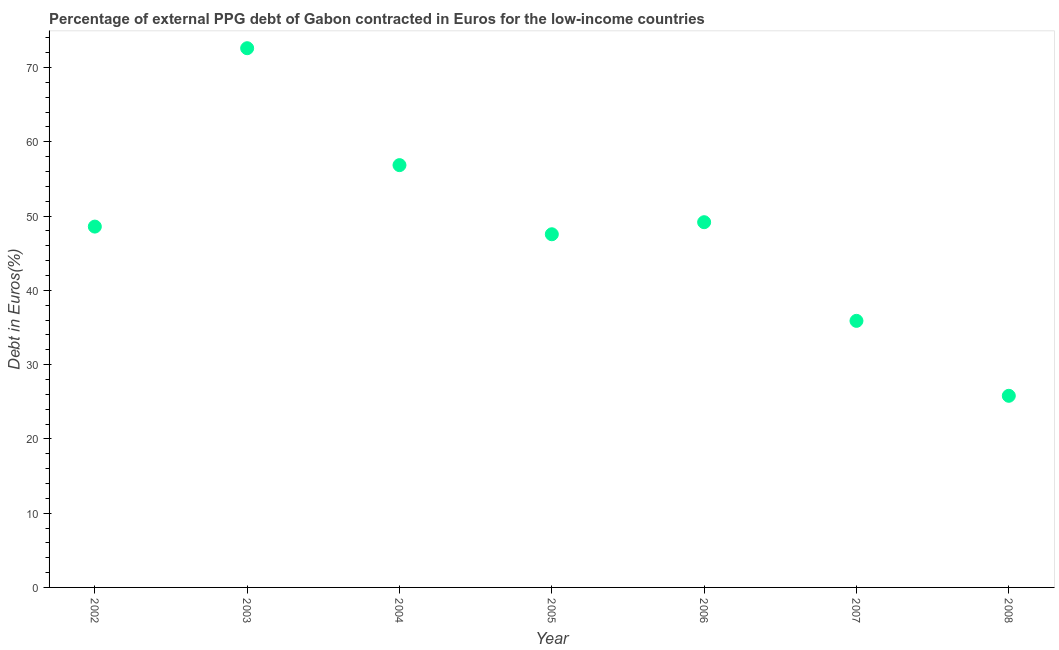What is the currency composition of ppg debt in 2002?
Give a very brief answer. 48.59. Across all years, what is the maximum currency composition of ppg debt?
Make the answer very short. 72.61. Across all years, what is the minimum currency composition of ppg debt?
Keep it short and to the point. 25.8. In which year was the currency composition of ppg debt maximum?
Offer a terse response. 2003. What is the sum of the currency composition of ppg debt?
Provide a short and direct response. 336.48. What is the difference between the currency composition of ppg debt in 2005 and 2008?
Provide a short and direct response. 21.75. What is the average currency composition of ppg debt per year?
Make the answer very short. 48.07. What is the median currency composition of ppg debt?
Your answer should be very brief. 48.59. In how many years, is the currency composition of ppg debt greater than 66 %?
Offer a terse response. 1. What is the ratio of the currency composition of ppg debt in 2002 to that in 2007?
Offer a terse response. 1.35. Is the difference between the currency composition of ppg debt in 2003 and 2008 greater than the difference between any two years?
Keep it short and to the point. Yes. What is the difference between the highest and the second highest currency composition of ppg debt?
Your response must be concise. 15.74. Is the sum of the currency composition of ppg debt in 2005 and 2006 greater than the maximum currency composition of ppg debt across all years?
Your response must be concise. Yes. What is the difference between the highest and the lowest currency composition of ppg debt?
Offer a terse response. 46.8. Does the currency composition of ppg debt monotonically increase over the years?
Offer a very short reply. No. What is the difference between two consecutive major ticks on the Y-axis?
Provide a succinct answer. 10. Does the graph contain any zero values?
Keep it short and to the point. No. What is the title of the graph?
Keep it short and to the point. Percentage of external PPG debt of Gabon contracted in Euros for the low-income countries. What is the label or title of the Y-axis?
Provide a succinct answer. Debt in Euros(%). What is the Debt in Euros(%) in 2002?
Provide a short and direct response. 48.59. What is the Debt in Euros(%) in 2003?
Your answer should be very brief. 72.61. What is the Debt in Euros(%) in 2004?
Offer a terse response. 56.86. What is the Debt in Euros(%) in 2005?
Provide a short and direct response. 47.55. What is the Debt in Euros(%) in 2006?
Your answer should be compact. 49.18. What is the Debt in Euros(%) in 2007?
Your answer should be compact. 35.89. What is the Debt in Euros(%) in 2008?
Provide a succinct answer. 25.8. What is the difference between the Debt in Euros(%) in 2002 and 2003?
Give a very brief answer. -24.02. What is the difference between the Debt in Euros(%) in 2002 and 2004?
Keep it short and to the point. -8.28. What is the difference between the Debt in Euros(%) in 2002 and 2005?
Keep it short and to the point. 1.03. What is the difference between the Debt in Euros(%) in 2002 and 2006?
Your response must be concise. -0.59. What is the difference between the Debt in Euros(%) in 2002 and 2007?
Provide a succinct answer. 12.69. What is the difference between the Debt in Euros(%) in 2002 and 2008?
Make the answer very short. 22.78. What is the difference between the Debt in Euros(%) in 2003 and 2004?
Make the answer very short. 15.74. What is the difference between the Debt in Euros(%) in 2003 and 2005?
Make the answer very short. 25.05. What is the difference between the Debt in Euros(%) in 2003 and 2006?
Provide a succinct answer. 23.43. What is the difference between the Debt in Euros(%) in 2003 and 2007?
Provide a short and direct response. 36.71. What is the difference between the Debt in Euros(%) in 2003 and 2008?
Your answer should be very brief. 46.8. What is the difference between the Debt in Euros(%) in 2004 and 2005?
Provide a short and direct response. 9.31. What is the difference between the Debt in Euros(%) in 2004 and 2006?
Make the answer very short. 7.68. What is the difference between the Debt in Euros(%) in 2004 and 2007?
Your answer should be very brief. 20.97. What is the difference between the Debt in Euros(%) in 2004 and 2008?
Offer a very short reply. 31.06. What is the difference between the Debt in Euros(%) in 2005 and 2006?
Your response must be concise. -1.62. What is the difference between the Debt in Euros(%) in 2005 and 2007?
Offer a terse response. 11.66. What is the difference between the Debt in Euros(%) in 2005 and 2008?
Make the answer very short. 21.75. What is the difference between the Debt in Euros(%) in 2006 and 2007?
Your response must be concise. 13.29. What is the difference between the Debt in Euros(%) in 2006 and 2008?
Provide a succinct answer. 23.38. What is the difference between the Debt in Euros(%) in 2007 and 2008?
Keep it short and to the point. 10.09. What is the ratio of the Debt in Euros(%) in 2002 to that in 2003?
Offer a terse response. 0.67. What is the ratio of the Debt in Euros(%) in 2002 to that in 2004?
Provide a short and direct response. 0.85. What is the ratio of the Debt in Euros(%) in 2002 to that in 2006?
Give a very brief answer. 0.99. What is the ratio of the Debt in Euros(%) in 2002 to that in 2007?
Give a very brief answer. 1.35. What is the ratio of the Debt in Euros(%) in 2002 to that in 2008?
Ensure brevity in your answer.  1.88. What is the ratio of the Debt in Euros(%) in 2003 to that in 2004?
Your answer should be very brief. 1.28. What is the ratio of the Debt in Euros(%) in 2003 to that in 2005?
Provide a succinct answer. 1.53. What is the ratio of the Debt in Euros(%) in 2003 to that in 2006?
Provide a succinct answer. 1.48. What is the ratio of the Debt in Euros(%) in 2003 to that in 2007?
Provide a succinct answer. 2.02. What is the ratio of the Debt in Euros(%) in 2003 to that in 2008?
Your answer should be compact. 2.81. What is the ratio of the Debt in Euros(%) in 2004 to that in 2005?
Provide a short and direct response. 1.2. What is the ratio of the Debt in Euros(%) in 2004 to that in 2006?
Make the answer very short. 1.16. What is the ratio of the Debt in Euros(%) in 2004 to that in 2007?
Ensure brevity in your answer.  1.58. What is the ratio of the Debt in Euros(%) in 2004 to that in 2008?
Offer a terse response. 2.2. What is the ratio of the Debt in Euros(%) in 2005 to that in 2006?
Give a very brief answer. 0.97. What is the ratio of the Debt in Euros(%) in 2005 to that in 2007?
Provide a short and direct response. 1.32. What is the ratio of the Debt in Euros(%) in 2005 to that in 2008?
Provide a succinct answer. 1.84. What is the ratio of the Debt in Euros(%) in 2006 to that in 2007?
Your answer should be very brief. 1.37. What is the ratio of the Debt in Euros(%) in 2006 to that in 2008?
Your answer should be compact. 1.91. What is the ratio of the Debt in Euros(%) in 2007 to that in 2008?
Your answer should be very brief. 1.39. 